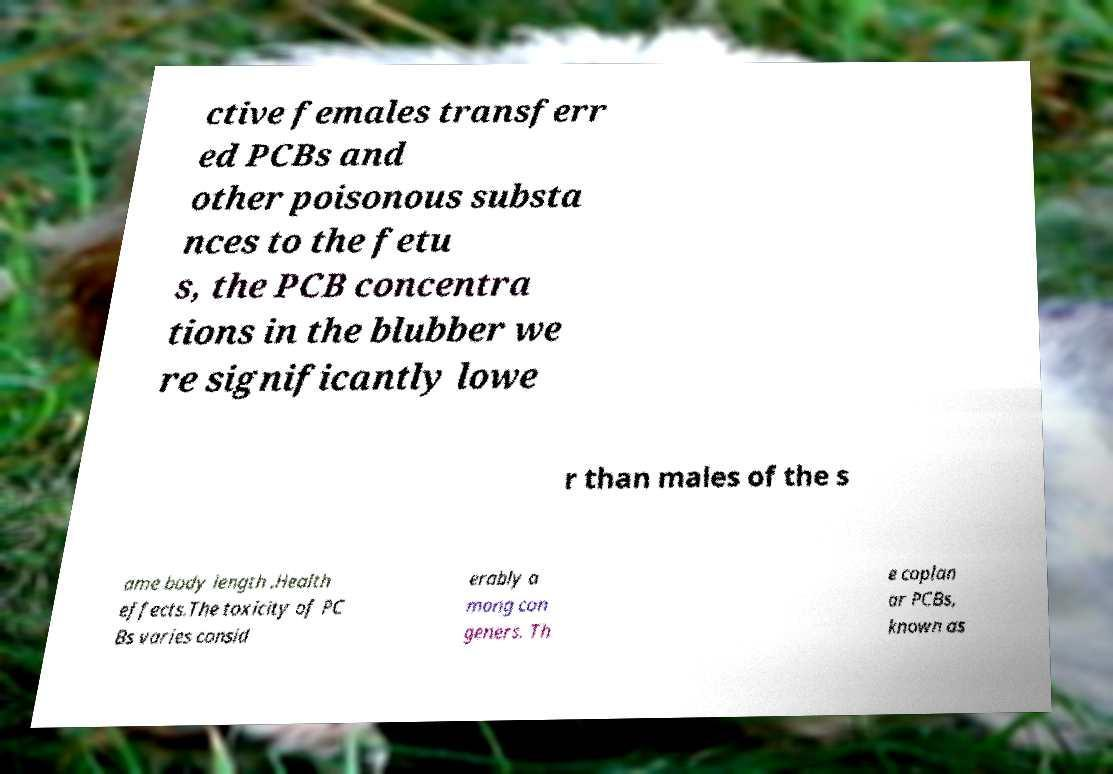I need the written content from this picture converted into text. Can you do that? ctive females transferr ed PCBs and other poisonous substa nces to the fetu s, the PCB concentra tions in the blubber we re significantly lowe r than males of the s ame body length .Health effects.The toxicity of PC Bs varies consid erably a mong con geners. Th e coplan ar PCBs, known as 